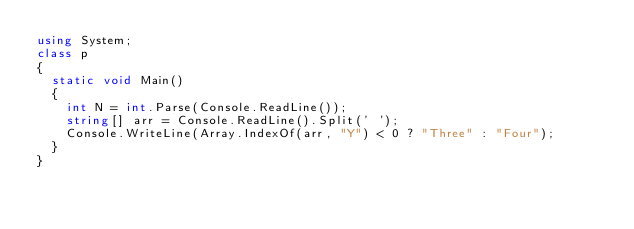<code> <loc_0><loc_0><loc_500><loc_500><_C#_>using System;
class p
{
  static void Main()
  {
    int N = int.Parse(Console.ReadLine());
    string[] arr = Console.ReadLine().Split(' ');
    Console.WriteLine(Array.IndexOf(arr, "Y") < 0 ? "Three" : "Four");
  }
}</code> 